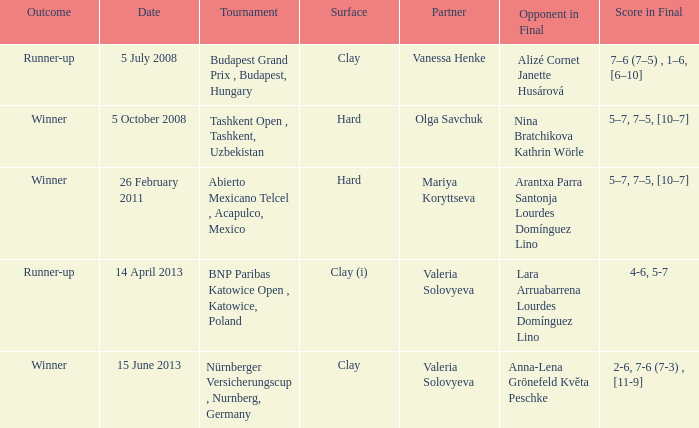Would you be able to parse every entry in this table? {'header': ['Outcome', 'Date', 'Tournament', 'Surface', 'Partner', 'Opponent in Final', 'Score in Final'], 'rows': [['Runner-up', '5 July 2008', 'Budapest Grand Prix , Budapest, Hungary', 'Clay', 'Vanessa Henke', 'Alizé Cornet Janette Husárová', '7–6 (7–5) , 1–6, [6–10]'], ['Winner', '5 October 2008', 'Tashkent Open , Tashkent, Uzbekistan', 'Hard', 'Olga Savchuk', 'Nina Bratchikova Kathrin Wörle', '5–7, 7–5, [10–7]'], ['Winner', '26 February 2011', 'Abierto Mexicano Telcel , Acapulco, Mexico', 'Hard', 'Mariya Koryttseva', 'Arantxa Parra Santonja Lourdes Domínguez Lino', '5–7, 7–5, [10–7]'], ['Runner-up', '14 April 2013', 'BNP Paribas Katowice Open , Katowice, Poland', 'Clay (i)', 'Valeria Solovyeva', 'Lara Arruabarrena Lourdes Domínguez Lino', '4-6, 5-7'], ['Winner', '15 June 2013', 'Nürnberger Versicherungscup , Nurnberg, Germany', 'Clay', 'Valeria Solovyeva', 'Anna-Lena Grönefeld Květa Peschke', '2-6, 7-6 (7-3) , [11-9]']]} Name the outcome for alizé cornet janette husárová being opponent in final Runner-up. 